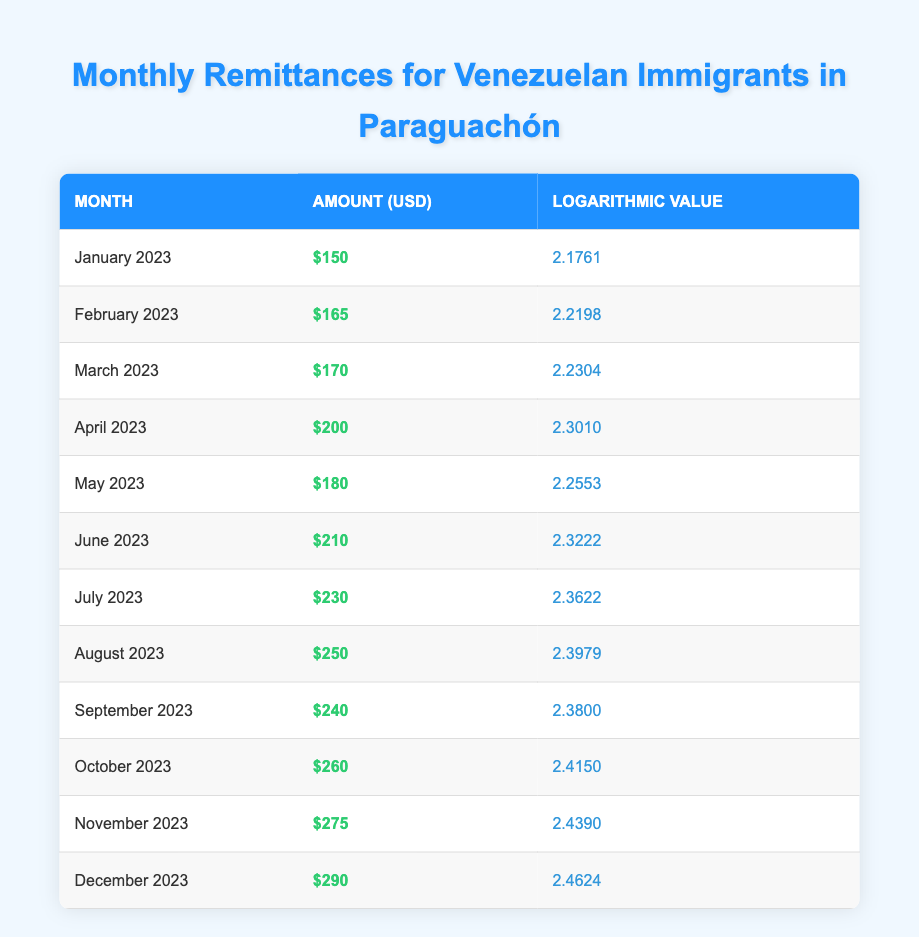What was the highest amount of remittances received in a single month? The highest amount listed is for December 2023, which shows $290. I found this by reviewing the "Amount (USD)" column to identify the maximum value.
Answer: 290 What was the logarithmic value for July 2023? The logarithmic value for July 2023 can be directly sourced from the table, which indicates it as 2.3622.
Answer: 2.3622 Which month had a lower remittance amount, March or May? March 2023 had $170 and May 2023 had $180. Since 170 is less than 180, March had a lower remittance amount.
Answer: March 2023 What is the average remittance amount received from January to March 2023? The remittance amounts for January ($150), February ($165), and March ($170) total to $485. Dividing this total by the number of months (3) gives an average of $485 / 3 = $161.67.
Answer: 161.67 Did the remittances increase every month from January to December 2023? By reviewing the monthly amounts, I noticed that while most months showed increases, September had $240, and August was $250, indicating a decrease from August to September. Thus, the remittances did not increase every month.
Answer: No What was the logarithmic value change from February to April 2023? The logarithmic value for February 2023 is 2.2198 and for April 2023 is 2.3010. The change is calculated as 2.3010 - 2.2198 = 0.0812, indicating an increase.
Answer: 0.0812 In which month did the remittance amount first exceed $200? According to the table, the first month when the remittance amount exceeded $200 was April 2023, with a recorded amount of $200.
Answer: April 2023 What is the total remittance amount received over the year 2023? To find the total remittance amount, we need to sum all monthly remittances: 150 + 165 + 170 + 200 + 180 + 210 + 230 + 250 + 240 + 260 + 275 + 290 = 2,300.
Answer: 2300 What is the difference between the maximum and minimum remittance amounts in 2023? The maximum remittance amount is $290 for December 2023 and the minimum is $150 for January 2023. The difference is $290 - $150 = $140.
Answer: 140 